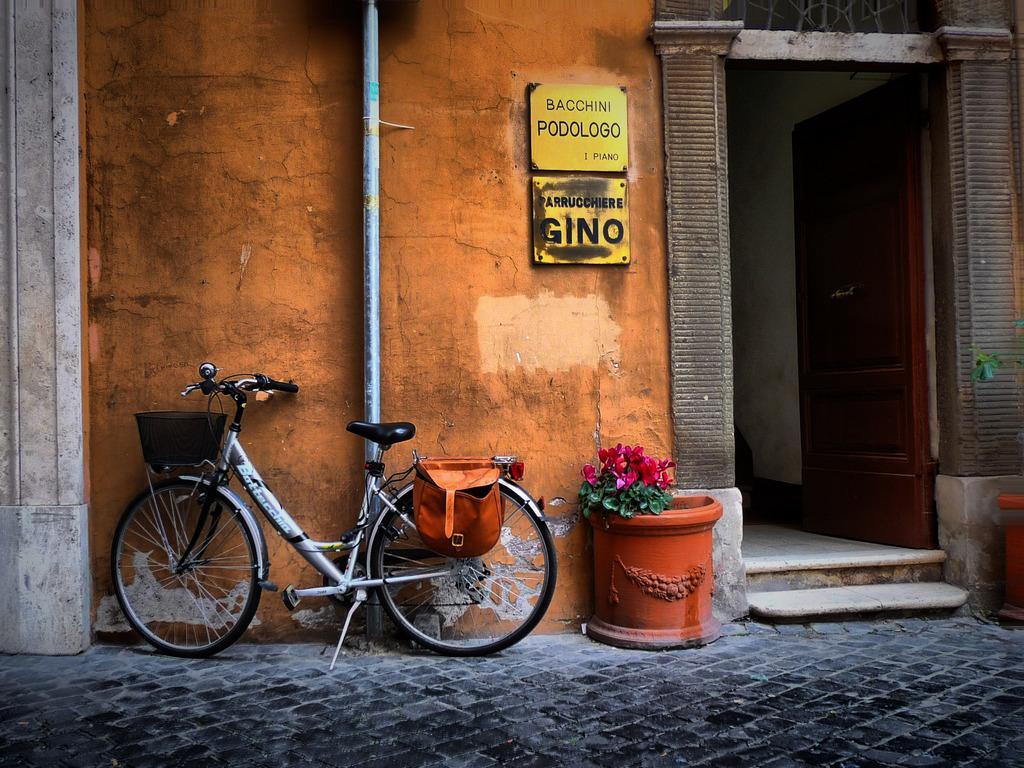How would you summarize this image in a sentence or two? In this image we can see there is a cycle parked on the path of a road, beside the cycle there is a flower pot. In the background of the image there is a building. 